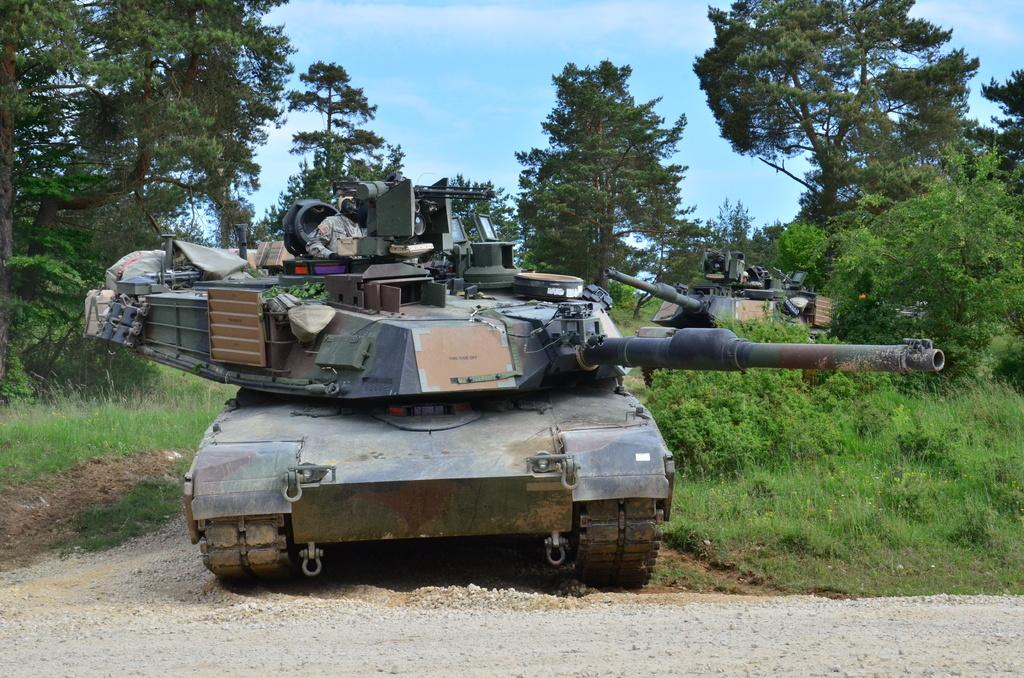What is the main subject in the image? There is a vehicle in the image. What can be seen in the background of the image? There are trees and the sky visible in the background of the image. What is the color of the trees in the image? The trees are green. How would you describe the sky in the image? The sky has both blue and white colors. Is there a rifle visible in the image? No, there is no rifle present in the image; it only features a vehicle, trees, and the sky. 